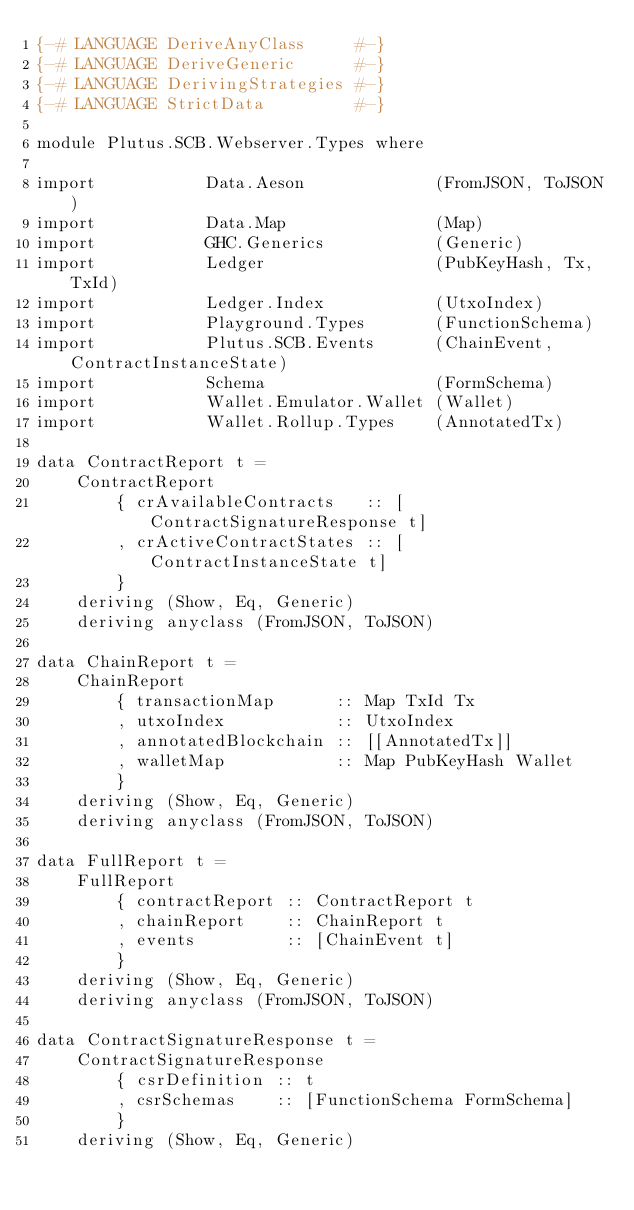<code> <loc_0><loc_0><loc_500><loc_500><_Haskell_>{-# LANGUAGE DeriveAnyClass     #-}
{-# LANGUAGE DeriveGeneric      #-}
{-# LANGUAGE DerivingStrategies #-}
{-# LANGUAGE StrictData         #-}

module Plutus.SCB.Webserver.Types where

import           Data.Aeson             (FromJSON, ToJSON)
import           Data.Map               (Map)
import           GHC.Generics           (Generic)
import           Ledger                 (PubKeyHash, Tx, TxId)
import           Ledger.Index           (UtxoIndex)
import           Playground.Types       (FunctionSchema)
import           Plutus.SCB.Events      (ChainEvent, ContractInstanceState)
import           Schema                 (FormSchema)
import           Wallet.Emulator.Wallet (Wallet)
import           Wallet.Rollup.Types    (AnnotatedTx)

data ContractReport t =
    ContractReport
        { crAvailableContracts   :: [ContractSignatureResponse t]
        , crActiveContractStates :: [ContractInstanceState t]
        }
    deriving (Show, Eq, Generic)
    deriving anyclass (FromJSON, ToJSON)

data ChainReport t =
    ChainReport
        { transactionMap      :: Map TxId Tx
        , utxoIndex           :: UtxoIndex
        , annotatedBlockchain :: [[AnnotatedTx]]
        , walletMap           :: Map PubKeyHash Wallet
        }
    deriving (Show, Eq, Generic)
    deriving anyclass (FromJSON, ToJSON)

data FullReport t =
    FullReport
        { contractReport :: ContractReport t
        , chainReport    :: ChainReport t
        , events         :: [ChainEvent t]
        }
    deriving (Show, Eq, Generic)
    deriving anyclass (FromJSON, ToJSON)

data ContractSignatureResponse t =
    ContractSignatureResponse
        { csrDefinition :: t
        , csrSchemas    :: [FunctionSchema FormSchema]
        }
    deriving (Show, Eq, Generic)</code> 